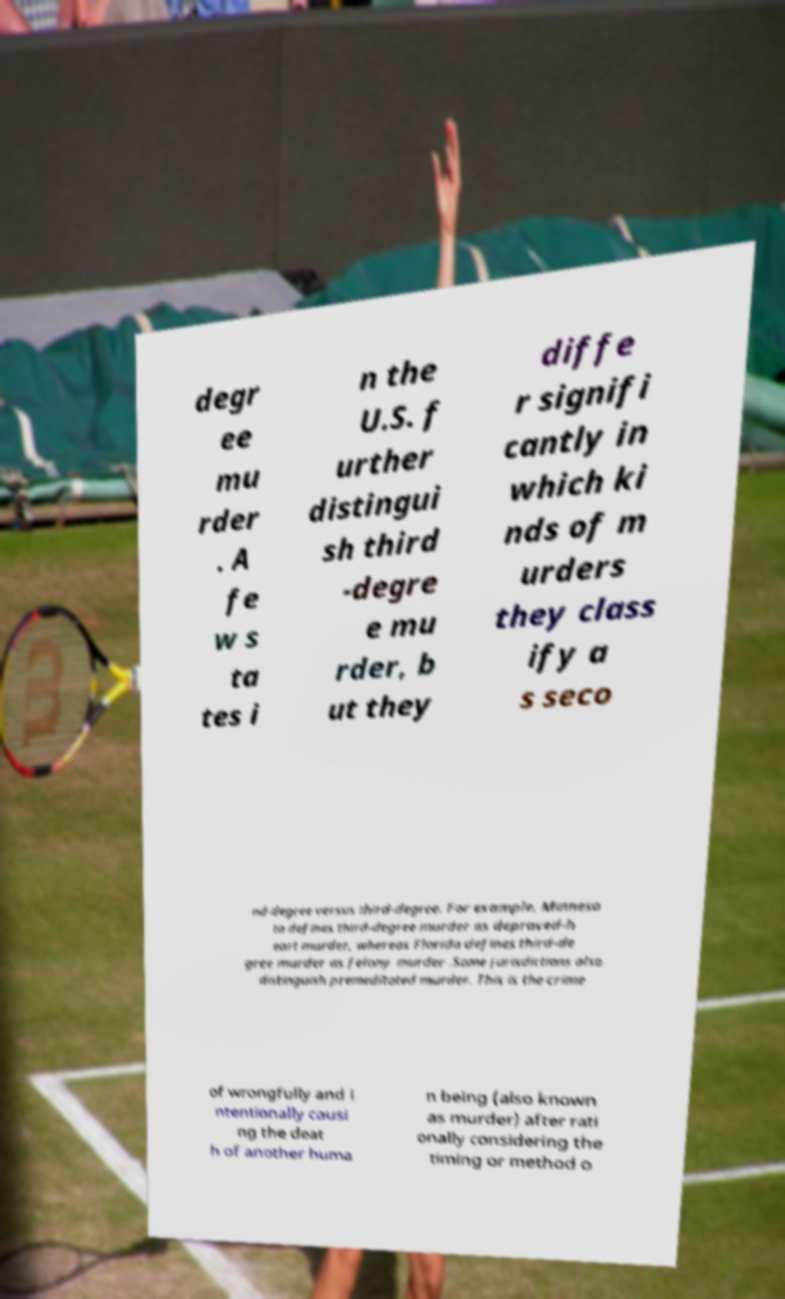For documentation purposes, I need the text within this image transcribed. Could you provide that? degr ee mu rder . A fe w s ta tes i n the U.S. f urther distingui sh third -degre e mu rder, b ut they diffe r signifi cantly in which ki nds of m urders they class ify a s seco nd-degree versus third-degree. For example, Minneso ta defines third-degree murder as depraved-h eart murder, whereas Florida defines third-de gree murder as felony murder .Some jurisdictions also distinguish premeditated murder. This is the crime of wrongfully and i ntentionally causi ng the deat h of another huma n being (also known as murder) after rati onally considering the timing or method o 